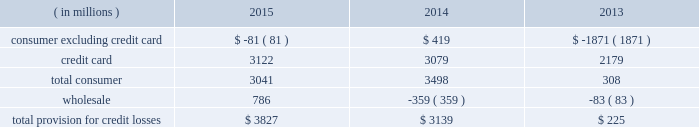Jpmorgan chase & co./2015 annual report 73 in advisory fees was driven by the combined impact of a greater share of fees for completed transactions , and growth in industry-wide fees .
The increase in equity underwriting fees was driven by higher industry-wide issuance .
The decrease in debt underwriting fees was primarily related to lower bond underwriting fees compared with the prior year , and lower loan syndication fees on lower industry-wide fees .
Principal transactions revenue increased as the prior year included a $ 1.5 billion loss related to the implementation of the funding valuation adjustment ( 201cfva 201d ) framework for over-the-counter ( 201cotc 201d ) derivatives and structured notes .
Private equity gains increased as a result of higher net gains on sales .
These increases were partially offset by lower fixed income markets revenue in cib , primarily driven by credit-related and rates products , as well as the impact of business simplification initiatives .
Lending- and deposit-related fees decreased compared with the prior year , reflecting the impact of business simplification initiatives and lower trade finance revenue in cib .
Asset management , administration and commissions revenue increased compared with the prior year , reflecting higher asset management fees driven by net client inflows and higher market levels in am and ccb .
The increase was offset partially by lower commissions and other fee revenue in ccb as a result of the exit of a non-core product in 2013 .
Securities gains decreased compared with the prior year , reflecting lower repositioning activity related to the firm 2019s investment securities portfolio .
Mortgage fees and related income decreased compared with the prior year , predominantly due to lower net production revenue driven by lower volumes due to higher mortgage interest rates , and tighter margins .
The decline in net production revenue was partially offset by a lower loss on the risk management of mortgage servicing rights ( 201cmsrs 201d ) .
Card income was relatively flat compared with the prior year , but included higher net interchange income due to growth in credit and debit card sales volume , offset by higher amortization of new account origination costs .
Other income decreased from the prior year , predominantly from the absence of two significant items recorded in corporate in 2013 : gains of $ 1.3 billion and $ 493 million from sales of visa shares and one chase manhattan plaza , respectively .
Lower valuations of seed capital investments in am and losses related to the exit of non-core portfolios in card also contributed to the decrease .
These items were partially offset by higher auto lease income as a result of growth in auto lease volume , and a benefit from a tax settlement .
Net interest income increased slightly from the prior year , predominantly reflecting higher yields on investment securities , the impact of lower interest expense from lower rates , and higher average loan balances .
The increase was partially offset by lower yields on loans due to the run-off of higher-yielding loans and new originations of lower-yielding loans , and lower average interest-earning trading asset balances .
The firm 2019s average interest-earning assets were $ 2.0 trillion , and the net interest yield on these assets , on a fte basis , was 2.18% ( 2.18 % ) , a decrease of 5 basis points from the prior year .
Provision for credit losses year ended december 31 .
2015 compared with 2014 the provision for credit losses increased from the prior year as a result of an increase in the wholesale provision , largely reflecting the impact of downgrades in the oil & gas portfolio .
The increase was partially offset by a decrease in the consumer provision , reflecting lower net charge-offs due to continued discipline in credit underwriting , as well as improvement in the economy driven by increasing home prices and lower unemployment levels .
The increase was partially offset by a lower reduction in the allowance for loan losses .
For a more detailed discussion of the credit portfolio and the allowance for credit losses , see the segment discussions of ccb on pages 85 201393 , cb on pages 99 2013101 , and the allowance for credit losses on pages 130 2013132 .
2014 compared with 2013 the provision for credit losses increased by $ 2.9 billion from the prior year as result of a lower benefit from reductions in the consumer allowance for loan losses , partially offset by lower net charge-offs .
The consumer allowance reduction in 2014 was primarily related to the consumer , excluding credit card , portfolio and reflected the continued improvement in home prices and delinquencies in the residential real estate portfolio .
The wholesale provision reflected a continued favorable credit environment. .
Based on the information of the firm 2019s average interest-earning assets were $ 2.0 trillion , and the net interest yield on these assets , on a fte basis , of 2.18% ( 2.18 % ) what was the approximate interest income in billions? 
Computations: (2 + 2.18)
Answer: 4.18. 